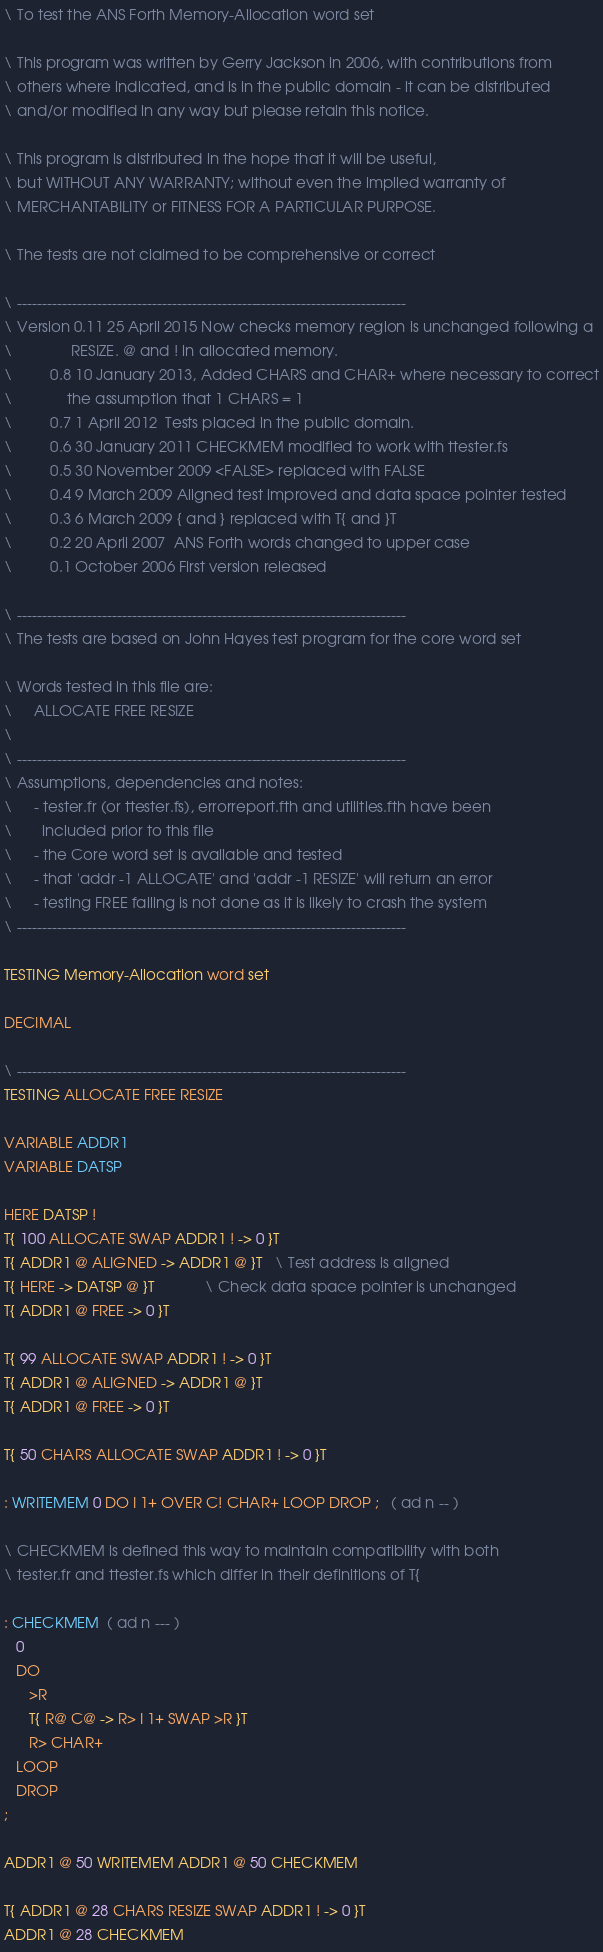Convert code to text. <code><loc_0><loc_0><loc_500><loc_500><_Forth_>\ To test the ANS Forth Memory-Allocation word set

\ This program was written by Gerry Jackson in 2006, with contributions from
\ others where indicated, and is in the public domain - it can be distributed
\ and/or modified in any way but please retain this notice.

\ This program is distributed in the hope that it will be useful,
\ but WITHOUT ANY WARRANTY; without even the implied warranty of
\ MERCHANTABILITY or FITNESS FOR A PARTICULAR PURPOSE.

\ The tests are not claimed to be comprehensive or correct 

\ ------------------------------------------------------------------------------
\ Version 0.11 25 April 2015 Now checks memory region is unchanged following a
\              RESIZE. @ and ! in allocated memory.
\         0.8 10 January 2013, Added CHARS and CHAR+ where necessary to correct
\             the assumption that 1 CHARS = 1
\         0.7 1 April 2012  Tests placed in the public domain.
\         0.6 30 January 2011 CHECKMEM modified to work with ttester.fs
\         0.5 30 November 2009 <FALSE> replaced with FALSE
\         0.4 9 March 2009 Aligned test improved and data space pointer tested
\         0.3 6 March 2009 { and } replaced with T{ and }T
\         0.2 20 April 2007  ANS Forth words changed to upper case
\         0.1 October 2006 First version released

\ ------------------------------------------------------------------------------
\ The tests are based on John Hayes test program for the core word set

\ Words tested in this file are:
\     ALLOCATE FREE RESIZE
\     
\ ------------------------------------------------------------------------------
\ Assumptions, dependencies and notes:
\     - tester.fr (or ttester.fs), errorreport.fth and utilities.fth have been
\       included prior to this file
\     - the Core word set is available and tested
\     - that 'addr -1 ALLOCATE' and 'addr -1 RESIZE' will return an error
\     - testing FREE failing is not done as it is likely to crash the system
\ ------------------------------------------------------------------------------

TESTING Memory-Allocation word set

DECIMAL

\ ------------------------------------------------------------------------------
TESTING ALLOCATE FREE RESIZE

VARIABLE ADDR1
VARIABLE DATSP

HERE DATSP !
T{ 100 ALLOCATE SWAP ADDR1 ! -> 0 }T
T{ ADDR1 @ ALIGNED -> ADDR1 @ }T   \ Test address is aligned
T{ HERE -> DATSP @ }T            \ Check data space pointer is unchanged
T{ ADDR1 @ FREE -> 0 }T

T{ 99 ALLOCATE SWAP ADDR1 ! -> 0 }T
T{ ADDR1 @ ALIGNED -> ADDR1 @ }T
T{ ADDR1 @ FREE -> 0 }T

T{ 50 CHARS ALLOCATE SWAP ADDR1 ! -> 0 }T

: WRITEMEM 0 DO I 1+ OVER C! CHAR+ LOOP DROP ;   ( ad n -- )

\ CHECKMEM is defined this way to maintain compatibility with both
\ tester.fr and ttester.fs which differ in their definitions of T{

: CHECKMEM  ( ad n --- )
   0
   DO
      >R
      T{ R@ C@ -> R> I 1+ SWAP >R }T
      R> CHAR+
   LOOP
   DROP
;

ADDR1 @ 50 WRITEMEM ADDR1 @ 50 CHECKMEM

T{ ADDR1 @ 28 CHARS RESIZE SWAP ADDR1 ! -> 0 }T
ADDR1 @ 28 CHECKMEM
</code> 